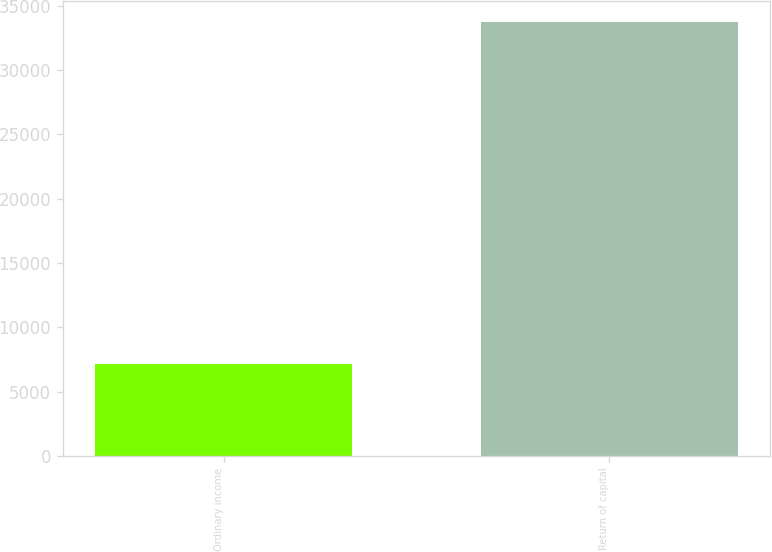Convert chart. <chart><loc_0><loc_0><loc_500><loc_500><bar_chart><fcel>Ordinary income<fcel>Return of capital<nl><fcel>7123<fcel>33719<nl></chart> 